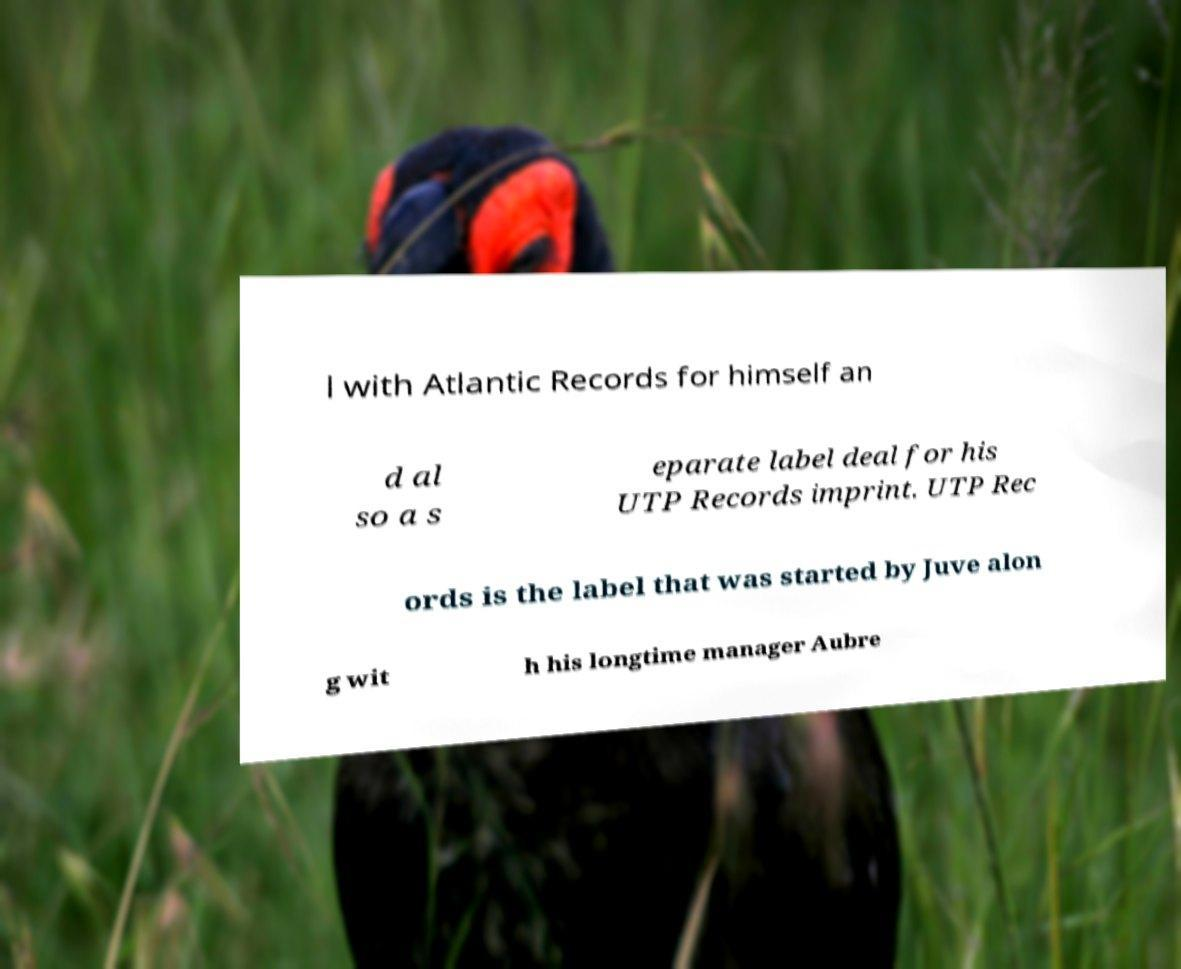What messages or text are displayed in this image? I need them in a readable, typed format. l with Atlantic Records for himself an d al so a s eparate label deal for his UTP Records imprint. UTP Rec ords is the label that was started by Juve alon g wit h his longtime manager Aubre 